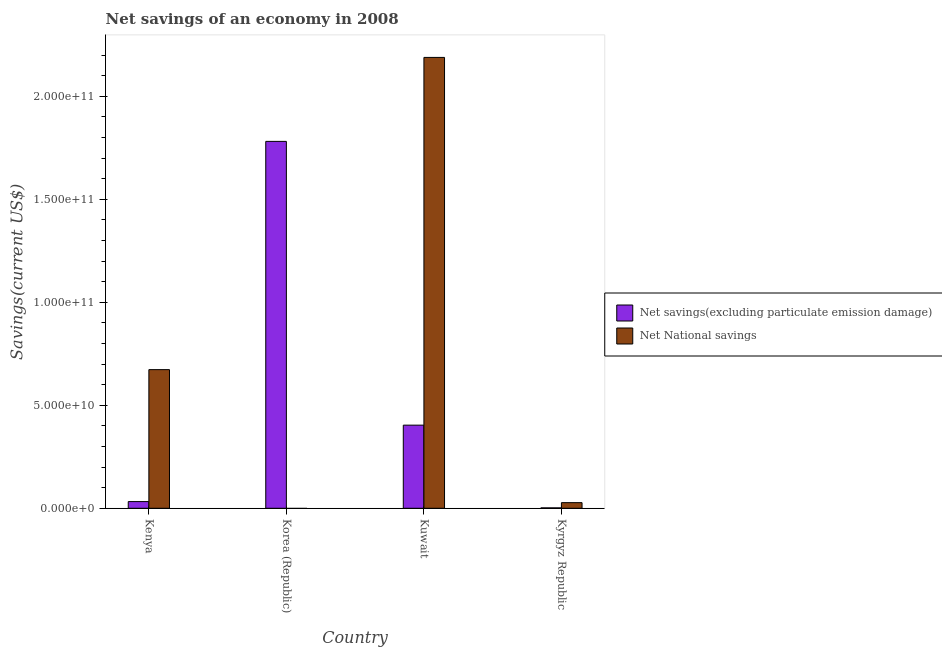How many different coloured bars are there?
Offer a very short reply. 2. Are the number of bars on each tick of the X-axis equal?
Your answer should be very brief. No. How many bars are there on the 3rd tick from the left?
Offer a terse response. 2. How many bars are there on the 3rd tick from the right?
Offer a very short reply. 1. What is the label of the 4th group of bars from the left?
Offer a very short reply. Kyrgyz Republic. In how many cases, is the number of bars for a given country not equal to the number of legend labels?
Your answer should be compact. 1. What is the net savings(excluding particulate emission damage) in Kuwait?
Give a very brief answer. 4.04e+1. Across all countries, what is the maximum net national savings?
Offer a very short reply. 2.19e+11. Across all countries, what is the minimum net savings(excluding particulate emission damage)?
Give a very brief answer. 1.99e+08. What is the total net savings(excluding particulate emission damage) in the graph?
Provide a short and direct response. 2.22e+11. What is the difference between the net savings(excluding particulate emission damage) in Kenya and that in Korea (Republic)?
Keep it short and to the point. -1.75e+11. What is the difference between the net national savings in Korea (Republic) and the net savings(excluding particulate emission damage) in Kuwait?
Offer a very short reply. -4.04e+1. What is the average net national savings per country?
Keep it short and to the point. 7.22e+1. What is the difference between the net national savings and net savings(excluding particulate emission damage) in Kyrgyz Republic?
Offer a terse response. 2.53e+09. In how many countries, is the net savings(excluding particulate emission damage) greater than 170000000000 US$?
Give a very brief answer. 1. What is the ratio of the net national savings in Kenya to that in Kuwait?
Your answer should be compact. 0.31. Is the net savings(excluding particulate emission damage) in Kenya less than that in Kyrgyz Republic?
Your answer should be compact. No. What is the difference between the highest and the second highest net savings(excluding particulate emission damage)?
Offer a very short reply. 1.38e+11. What is the difference between the highest and the lowest net national savings?
Your response must be concise. 2.19e+11. Is the sum of the net national savings in Kuwait and Kyrgyz Republic greater than the maximum net savings(excluding particulate emission damage) across all countries?
Your answer should be compact. Yes. How many bars are there?
Offer a terse response. 7. Are all the bars in the graph horizontal?
Make the answer very short. No. Are the values on the major ticks of Y-axis written in scientific E-notation?
Give a very brief answer. Yes. Where does the legend appear in the graph?
Offer a terse response. Center right. How many legend labels are there?
Your answer should be very brief. 2. What is the title of the graph?
Give a very brief answer. Net savings of an economy in 2008. Does "Import" appear as one of the legend labels in the graph?
Offer a terse response. No. What is the label or title of the X-axis?
Give a very brief answer. Country. What is the label or title of the Y-axis?
Provide a succinct answer. Savings(current US$). What is the Savings(current US$) of Net savings(excluding particulate emission damage) in Kenya?
Offer a terse response. 3.25e+09. What is the Savings(current US$) of Net National savings in Kenya?
Give a very brief answer. 6.73e+1. What is the Savings(current US$) in Net savings(excluding particulate emission damage) in Korea (Republic)?
Your answer should be compact. 1.78e+11. What is the Savings(current US$) of Net savings(excluding particulate emission damage) in Kuwait?
Provide a short and direct response. 4.04e+1. What is the Savings(current US$) in Net National savings in Kuwait?
Offer a very short reply. 2.19e+11. What is the Savings(current US$) in Net savings(excluding particulate emission damage) in Kyrgyz Republic?
Give a very brief answer. 1.99e+08. What is the Savings(current US$) of Net National savings in Kyrgyz Republic?
Make the answer very short. 2.73e+09. Across all countries, what is the maximum Savings(current US$) of Net savings(excluding particulate emission damage)?
Ensure brevity in your answer.  1.78e+11. Across all countries, what is the maximum Savings(current US$) in Net National savings?
Ensure brevity in your answer.  2.19e+11. Across all countries, what is the minimum Savings(current US$) of Net savings(excluding particulate emission damage)?
Your answer should be compact. 1.99e+08. Across all countries, what is the minimum Savings(current US$) in Net National savings?
Offer a very short reply. 0. What is the total Savings(current US$) in Net savings(excluding particulate emission damage) in the graph?
Provide a succinct answer. 2.22e+11. What is the total Savings(current US$) in Net National savings in the graph?
Keep it short and to the point. 2.89e+11. What is the difference between the Savings(current US$) of Net savings(excluding particulate emission damage) in Kenya and that in Korea (Republic)?
Your answer should be compact. -1.75e+11. What is the difference between the Savings(current US$) in Net savings(excluding particulate emission damage) in Kenya and that in Kuwait?
Give a very brief answer. -3.71e+1. What is the difference between the Savings(current US$) of Net National savings in Kenya and that in Kuwait?
Your answer should be very brief. -1.52e+11. What is the difference between the Savings(current US$) in Net savings(excluding particulate emission damage) in Kenya and that in Kyrgyz Republic?
Your response must be concise. 3.05e+09. What is the difference between the Savings(current US$) of Net National savings in Kenya and that in Kyrgyz Republic?
Provide a succinct answer. 6.46e+1. What is the difference between the Savings(current US$) in Net savings(excluding particulate emission damage) in Korea (Republic) and that in Kuwait?
Give a very brief answer. 1.38e+11. What is the difference between the Savings(current US$) in Net savings(excluding particulate emission damage) in Korea (Republic) and that in Kyrgyz Republic?
Give a very brief answer. 1.78e+11. What is the difference between the Savings(current US$) of Net savings(excluding particulate emission damage) in Kuwait and that in Kyrgyz Republic?
Make the answer very short. 4.02e+1. What is the difference between the Savings(current US$) in Net National savings in Kuwait and that in Kyrgyz Republic?
Give a very brief answer. 2.16e+11. What is the difference between the Savings(current US$) of Net savings(excluding particulate emission damage) in Kenya and the Savings(current US$) of Net National savings in Kuwait?
Your response must be concise. -2.16e+11. What is the difference between the Savings(current US$) of Net savings(excluding particulate emission damage) in Kenya and the Savings(current US$) of Net National savings in Kyrgyz Republic?
Offer a terse response. 5.14e+08. What is the difference between the Savings(current US$) of Net savings(excluding particulate emission damage) in Korea (Republic) and the Savings(current US$) of Net National savings in Kuwait?
Make the answer very short. -4.08e+1. What is the difference between the Savings(current US$) in Net savings(excluding particulate emission damage) in Korea (Republic) and the Savings(current US$) in Net National savings in Kyrgyz Republic?
Your answer should be very brief. 1.75e+11. What is the difference between the Savings(current US$) of Net savings(excluding particulate emission damage) in Kuwait and the Savings(current US$) of Net National savings in Kyrgyz Republic?
Offer a very short reply. 3.76e+1. What is the average Savings(current US$) in Net savings(excluding particulate emission damage) per country?
Your response must be concise. 5.55e+1. What is the average Savings(current US$) of Net National savings per country?
Provide a succinct answer. 7.22e+1. What is the difference between the Savings(current US$) in Net savings(excluding particulate emission damage) and Savings(current US$) in Net National savings in Kenya?
Ensure brevity in your answer.  -6.41e+1. What is the difference between the Savings(current US$) in Net savings(excluding particulate emission damage) and Savings(current US$) in Net National savings in Kuwait?
Your response must be concise. -1.79e+11. What is the difference between the Savings(current US$) of Net savings(excluding particulate emission damage) and Savings(current US$) of Net National savings in Kyrgyz Republic?
Provide a short and direct response. -2.53e+09. What is the ratio of the Savings(current US$) in Net savings(excluding particulate emission damage) in Kenya to that in Korea (Republic)?
Your response must be concise. 0.02. What is the ratio of the Savings(current US$) of Net savings(excluding particulate emission damage) in Kenya to that in Kuwait?
Keep it short and to the point. 0.08. What is the ratio of the Savings(current US$) of Net National savings in Kenya to that in Kuwait?
Provide a short and direct response. 0.31. What is the ratio of the Savings(current US$) in Net savings(excluding particulate emission damage) in Kenya to that in Kyrgyz Republic?
Offer a very short reply. 16.35. What is the ratio of the Savings(current US$) of Net National savings in Kenya to that in Kyrgyz Republic?
Give a very brief answer. 24.64. What is the ratio of the Savings(current US$) of Net savings(excluding particulate emission damage) in Korea (Republic) to that in Kuwait?
Offer a very short reply. 4.41. What is the ratio of the Savings(current US$) of Net savings(excluding particulate emission damage) in Korea (Republic) to that in Kyrgyz Republic?
Provide a succinct answer. 896.94. What is the ratio of the Savings(current US$) of Net savings(excluding particulate emission damage) in Kuwait to that in Kyrgyz Republic?
Give a very brief answer. 203.22. What is the ratio of the Savings(current US$) of Net National savings in Kuwait to that in Kyrgyz Republic?
Your response must be concise. 80.11. What is the difference between the highest and the second highest Savings(current US$) in Net savings(excluding particulate emission damage)?
Make the answer very short. 1.38e+11. What is the difference between the highest and the second highest Savings(current US$) of Net National savings?
Give a very brief answer. 1.52e+11. What is the difference between the highest and the lowest Savings(current US$) of Net savings(excluding particulate emission damage)?
Give a very brief answer. 1.78e+11. What is the difference between the highest and the lowest Savings(current US$) in Net National savings?
Ensure brevity in your answer.  2.19e+11. 